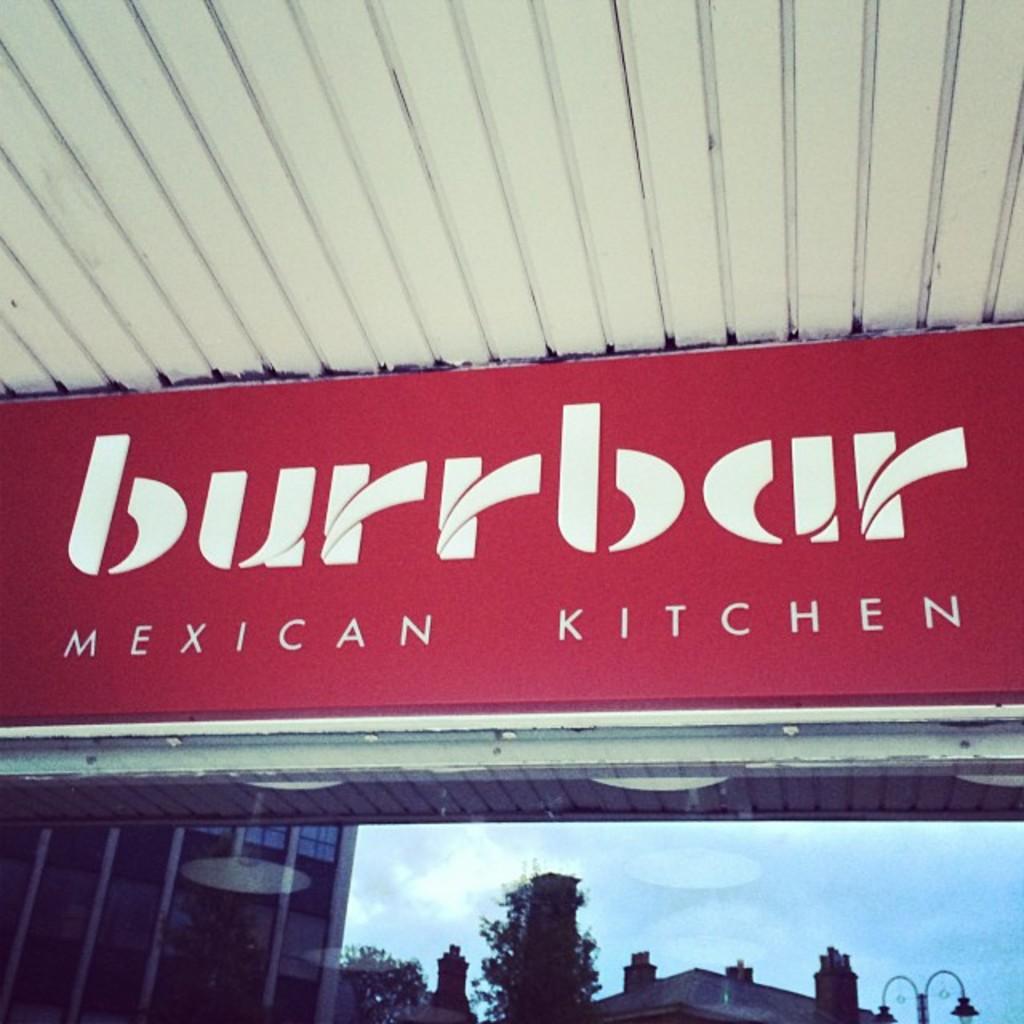What type of kitchen is the sign referencing?
Your answer should be compact. Mexican. What is the name of the kitchen?
Ensure brevity in your answer.  Burrbar. 